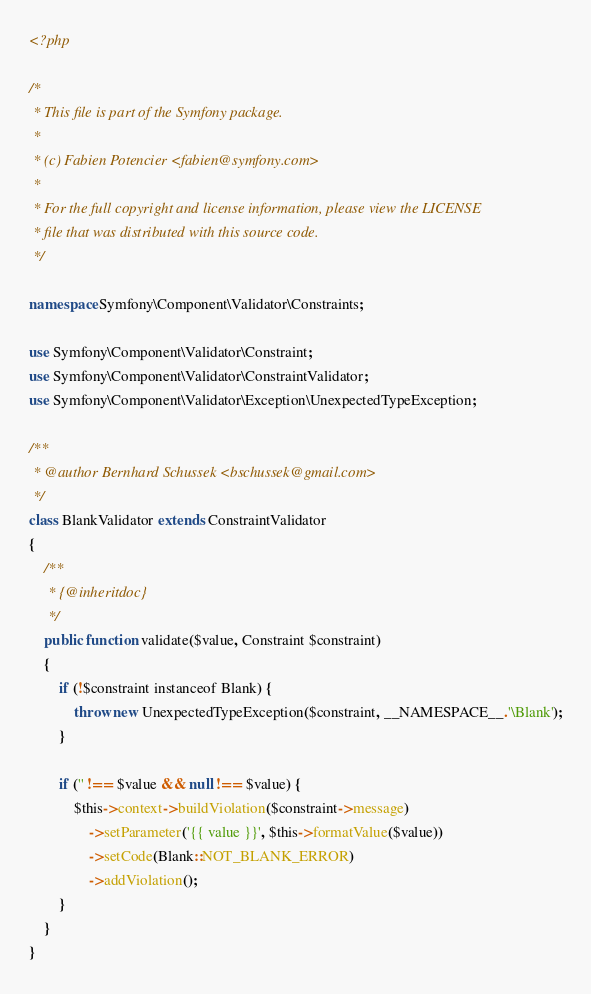Convert code to text. <code><loc_0><loc_0><loc_500><loc_500><_PHP_><?php

/*
 * This file is part of the Symfony package.
 *
 * (c) Fabien Potencier <fabien@symfony.com>
 *
 * For the full copyright and license information, please view the LICENSE
 * file that was distributed with this source code.
 */

namespace Symfony\Component\Validator\Constraints;

use Symfony\Component\Validator\Constraint;
use Symfony\Component\Validator\ConstraintValidator;
use Symfony\Component\Validator\Exception\UnexpectedTypeException;

/**
 * @author Bernhard Schussek <bschussek@gmail.com>
 */
class BlankValidator extends ConstraintValidator
{
    /**
     * {@inheritdoc}
     */
    public function validate($value, Constraint $constraint)
    {
        if (!$constraint instanceof Blank) {
            throw new UnexpectedTypeException($constraint, __NAMESPACE__.'\Blank');
        }

        if ('' !== $value && null !== $value) {
            $this->context->buildViolation($constraint->message)
                ->setParameter('{{ value }}', $this->formatValue($value))
                ->setCode(Blank::NOT_BLANK_ERROR)
                ->addViolation();
        }
    }
}
</code> 